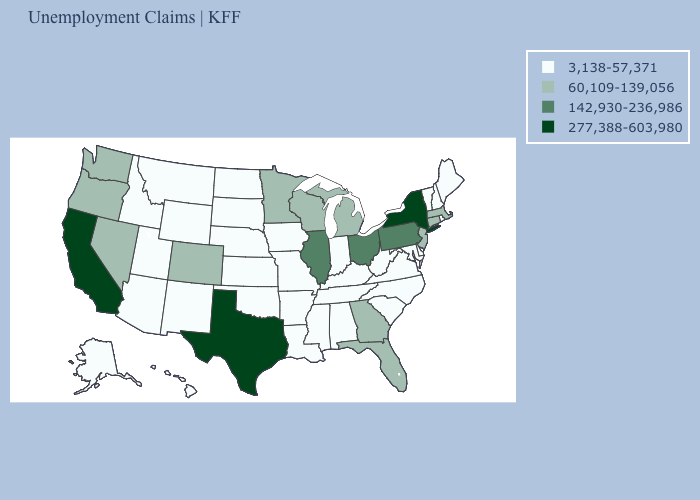Does the map have missing data?
Keep it brief. No. Among the states that border Arkansas , does Texas have the highest value?
Quick response, please. Yes. Name the states that have a value in the range 60,109-139,056?
Be succinct. Colorado, Connecticut, Florida, Georgia, Massachusetts, Michigan, Minnesota, Nevada, New Jersey, Oregon, Washington, Wisconsin. What is the value of Delaware?
Give a very brief answer. 3,138-57,371. What is the highest value in states that border West Virginia?
Concise answer only. 142,930-236,986. What is the value of Idaho?
Be succinct. 3,138-57,371. What is the highest value in states that border New York?
Short answer required. 142,930-236,986. Name the states that have a value in the range 142,930-236,986?
Be succinct. Illinois, Ohio, Pennsylvania. Name the states that have a value in the range 142,930-236,986?
Answer briefly. Illinois, Ohio, Pennsylvania. Which states have the lowest value in the USA?
Quick response, please. Alabama, Alaska, Arizona, Arkansas, Delaware, Hawaii, Idaho, Indiana, Iowa, Kansas, Kentucky, Louisiana, Maine, Maryland, Mississippi, Missouri, Montana, Nebraska, New Hampshire, New Mexico, North Carolina, North Dakota, Oklahoma, Rhode Island, South Carolina, South Dakota, Tennessee, Utah, Vermont, Virginia, West Virginia, Wyoming. Which states have the highest value in the USA?
Write a very short answer. California, New York, Texas. Name the states that have a value in the range 3,138-57,371?
Keep it brief. Alabama, Alaska, Arizona, Arkansas, Delaware, Hawaii, Idaho, Indiana, Iowa, Kansas, Kentucky, Louisiana, Maine, Maryland, Mississippi, Missouri, Montana, Nebraska, New Hampshire, New Mexico, North Carolina, North Dakota, Oklahoma, Rhode Island, South Carolina, South Dakota, Tennessee, Utah, Vermont, Virginia, West Virginia, Wyoming. What is the value of Montana?
Keep it brief. 3,138-57,371. What is the highest value in the Northeast ?
Write a very short answer. 277,388-603,980. Name the states that have a value in the range 142,930-236,986?
Write a very short answer. Illinois, Ohio, Pennsylvania. 